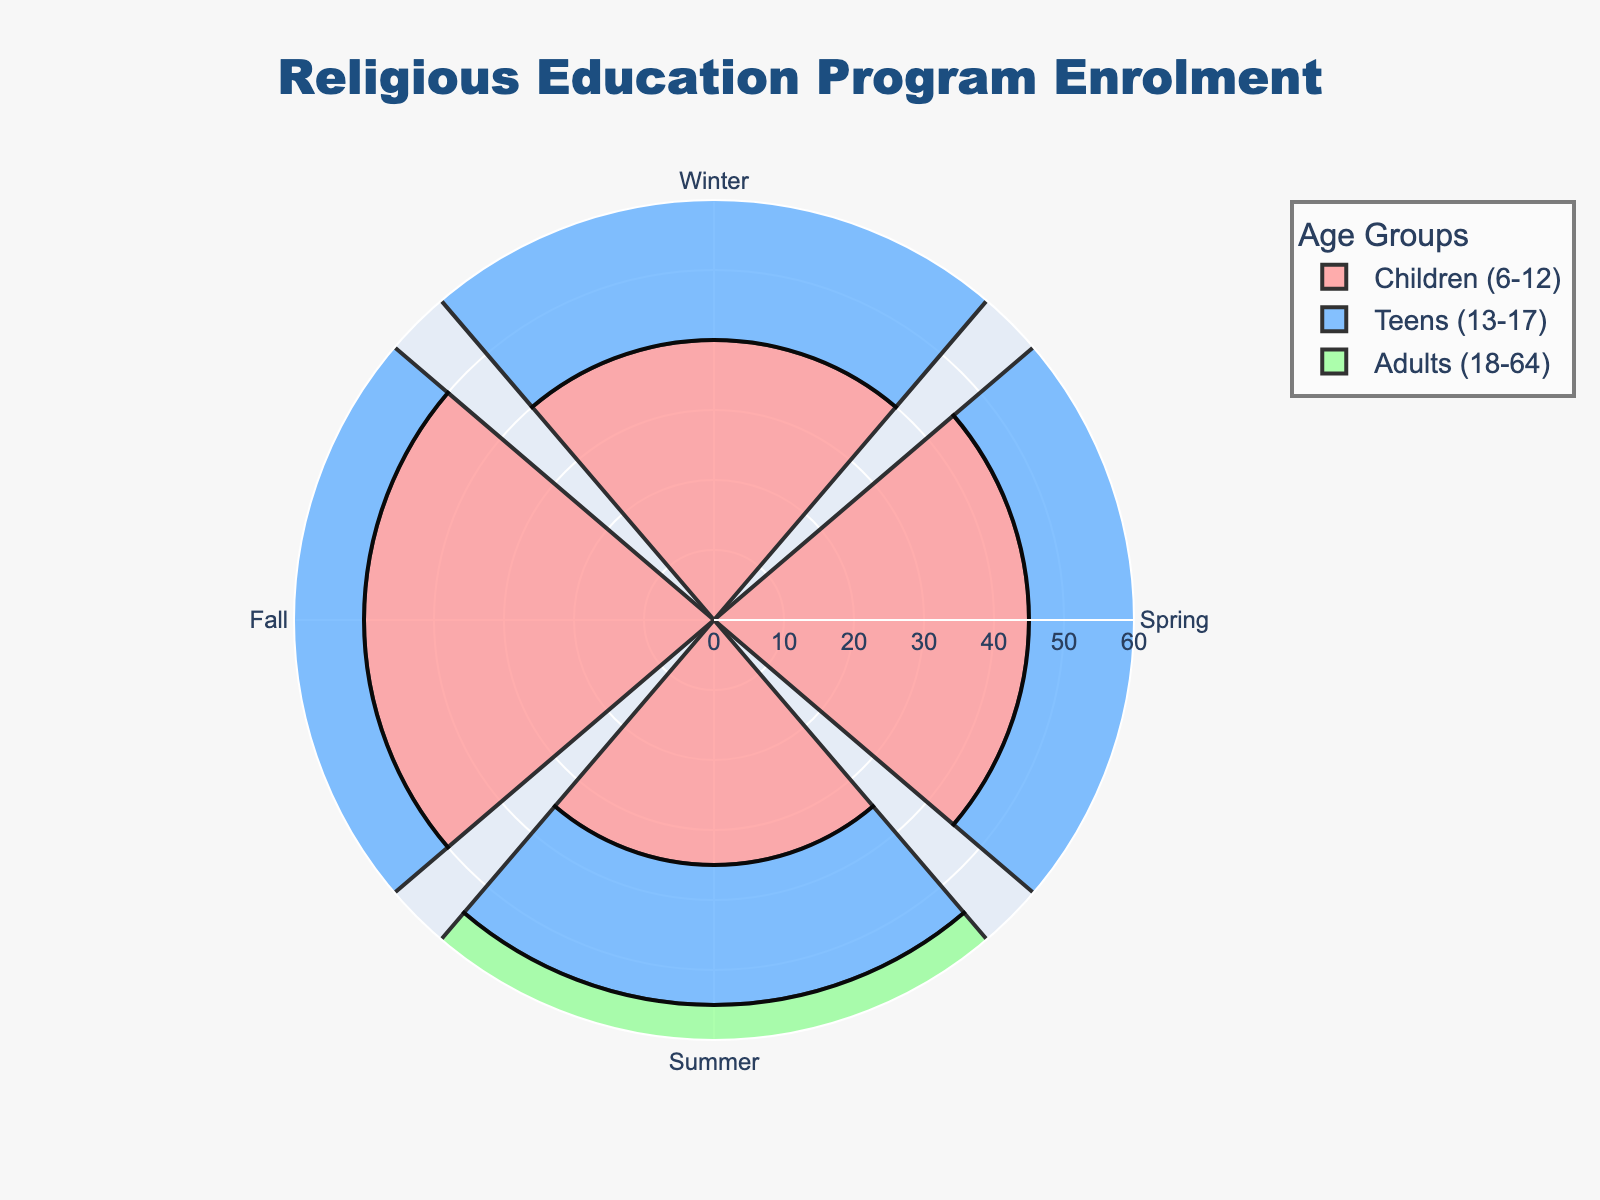How many seasons are represented in the figure? There are four seasons shown on the chart: Winter, Spring, Summer, and Fall.
Answer: Four Which age group has the highest enrolment in the Fall? Look at the plot section for Fall across different age groups. The 'Children (6-12)' category has the highest value.
Answer: Children (6-12) What is the maximum enrolment number for the Teens (13-17) age group? Identify the highest bar for the Teens (13-17) category on the polar chart. It reaches up to 30.
Answer: 30 What is the average enrolment for the Adults (18-64) age group across all seasons? Sum the enrolments of Adults across Winter (25), Spring (30), Summer (28), and Fall (35), and then divide by 4. (25+30+28+35)/4 = 118/4.
Answer: 29.5 Which season has the lowest total enrolment across all age groups? Sum the enrolments for each season: Winter (40 + 30 + 25 = 95), Spring (45 + 25 + 30 = 100), Summer (35 + 20 + 28 = 83), Fall (50 + 30 + 35 = 115). Summer has the lowest enrolment.
Answer: Summer Compare the enrolment for Children (6-12) in Winter and Summer. Which is greater? Find the values for Children (6-12) in Winter (40) and Summer (35) and compare them. Winter is greater.
Answer: Winter Which age group shows the most consistent enrolment across all seasons? Look at the bars for each age group and see which one has the least variation in height. Adults (18-64) have relatively consistent values.
Answer: Adults (18-64) How does the enrolment for Teens (13-17) in Spring compare with Adults (18-64) in Summer? Compare the values: Teens in Spring (25) and Adults in Summer (28). Adults in Summer is higher.
Answer: Adults (18-64) in Summer What is the total enrolment for all age groups in Winter? Sum the enrolments in Winter for Children (40), Teens (30), and Adults (25). 40 + 30 + 25 = 95.
Answer: 95 